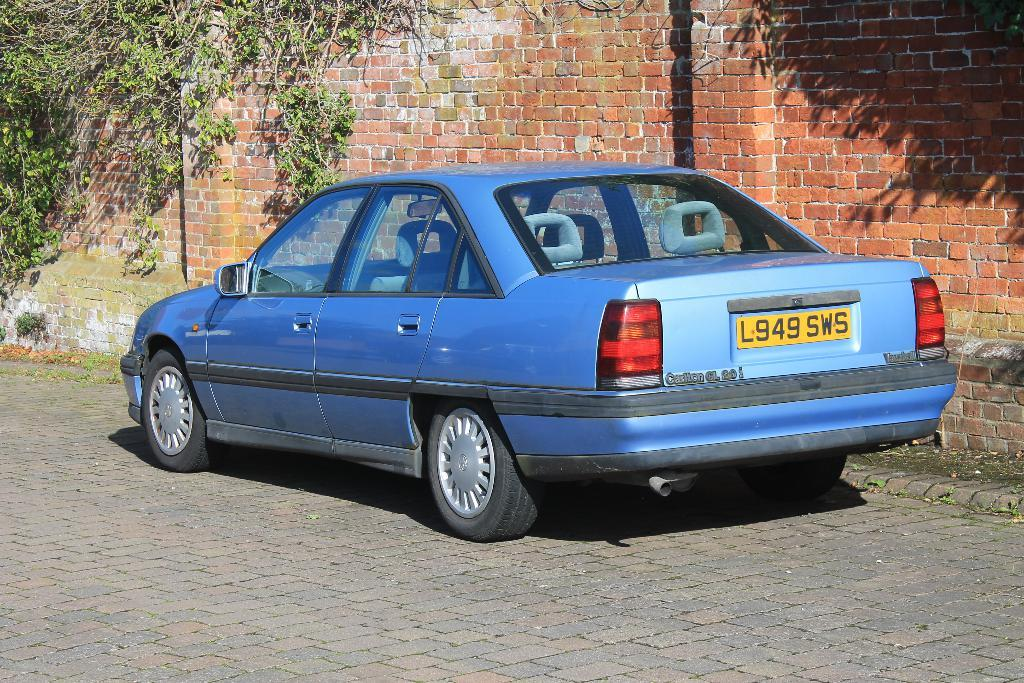What is the main object on the ground in the image? There is a car on the ground in the image. What can be seen in the background of the image? There are plants visible on a wall in the background of the image. How does the car slip on the ground in the image? The car does not slip on the ground in the image; it is stationary. What role do the plants play in the car's parenting in the image? The plants do not play any role in the car's parenting, as cars do not have the ability to parent. 